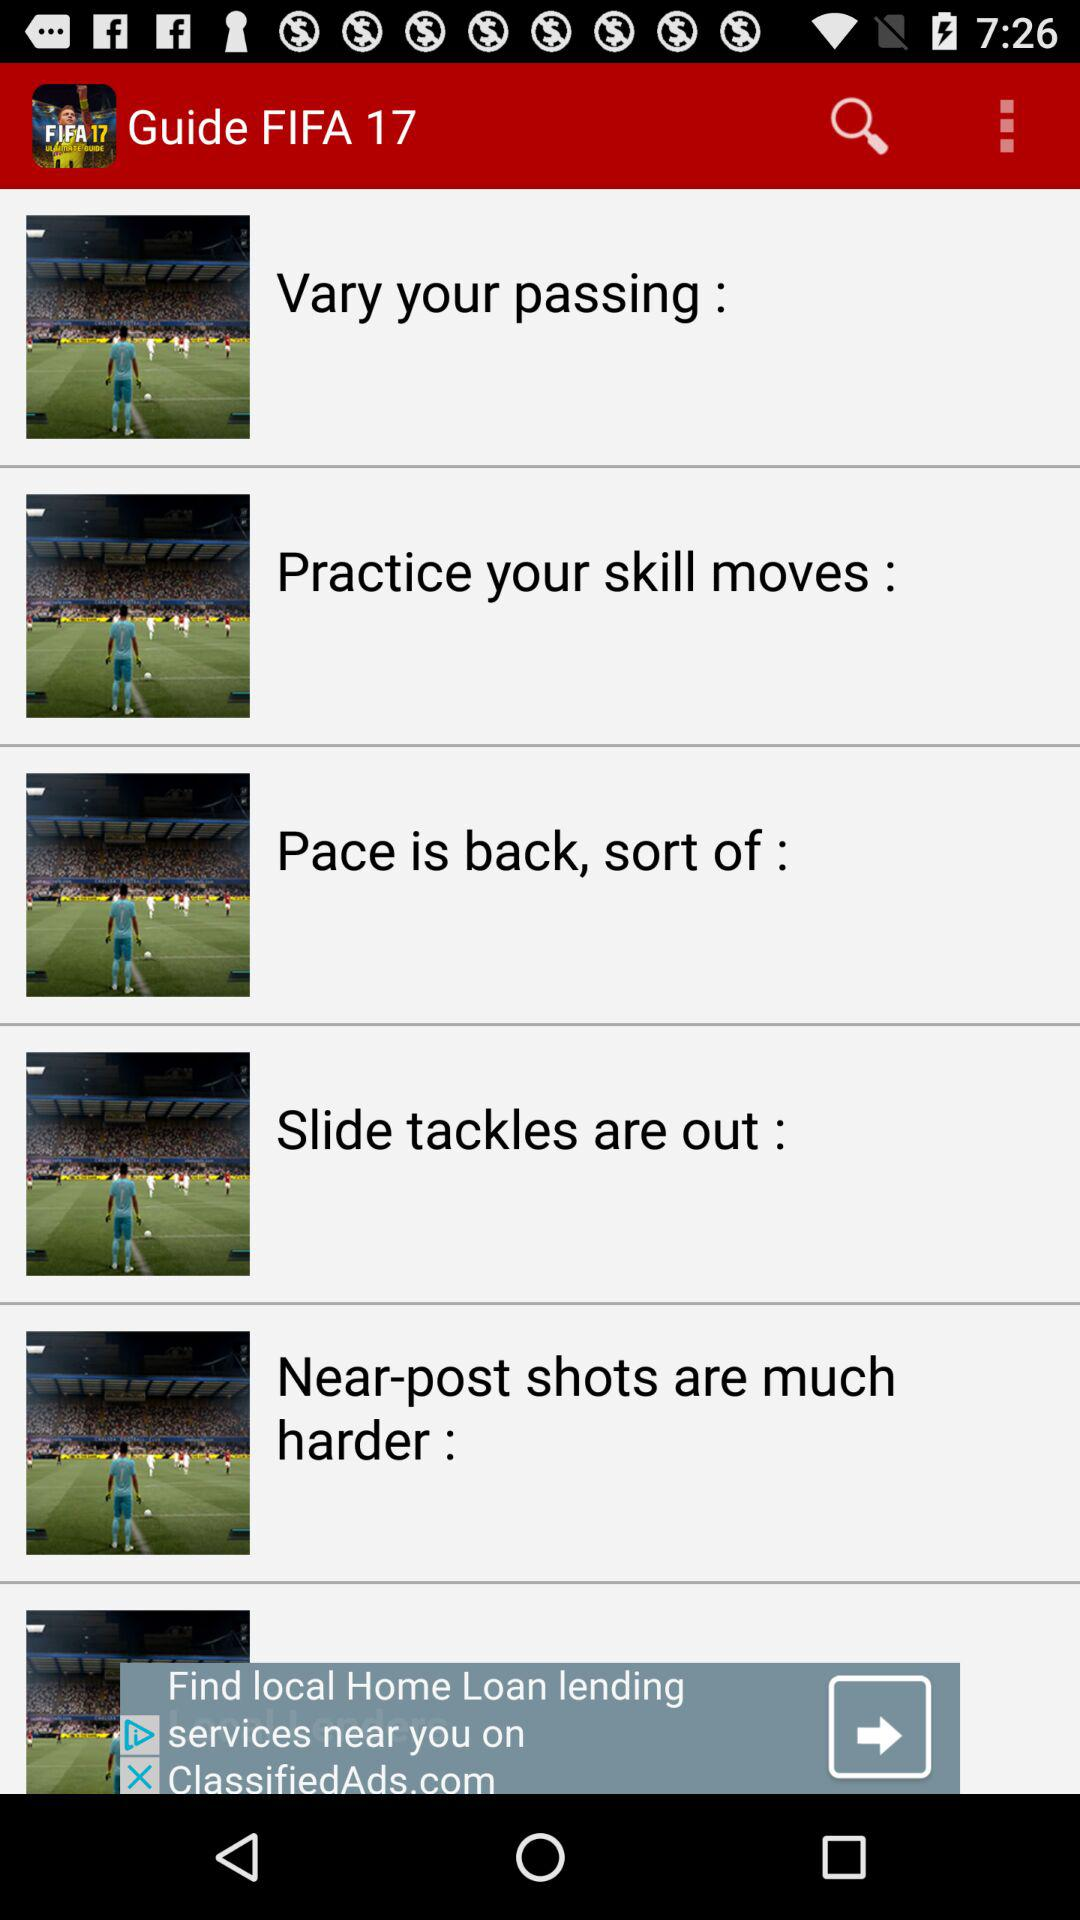How many tips are given in the guide?
Answer the question using a single word or phrase. 6 